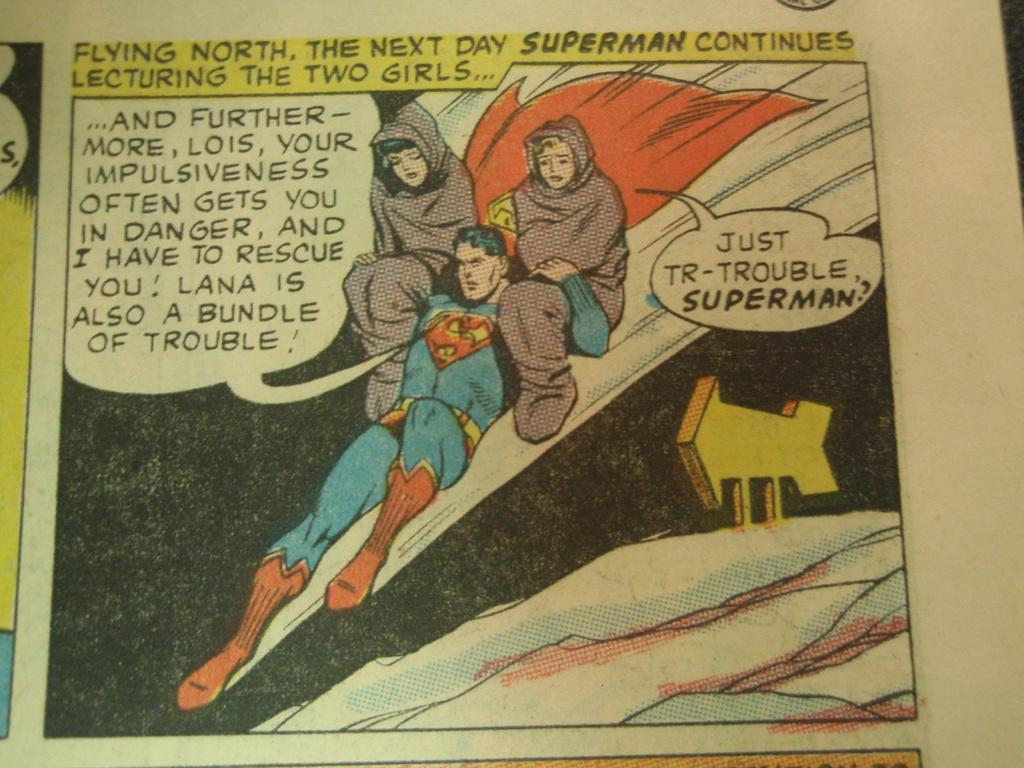<image>
Offer a succinct explanation of the picture presented. A cartoon panel has Superman lecturing two girls. 